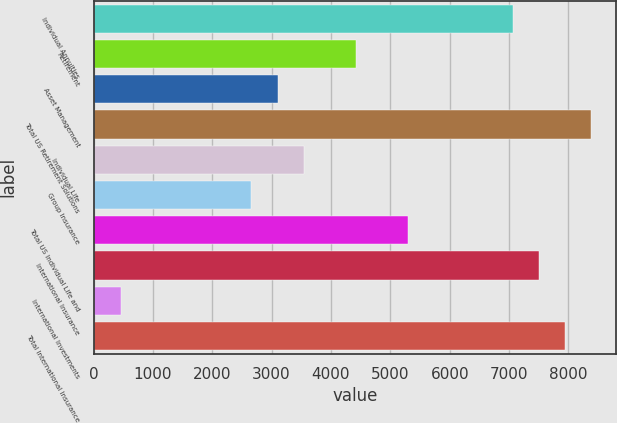Convert chart. <chart><loc_0><loc_0><loc_500><loc_500><bar_chart><fcel>Individual Annuities<fcel>Retirement<fcel>Asset Management<fcel>Total US Retirement Solutions<fcel>Individual Life<fcel>Group Insurance<fcel>Total US Individual Life and<fcel>International Insurance<fcel>International Investments<fcel>Total International Insurance<nl><fcel>7063.2<fcel>4422<fcel>3101.4<fcel>8383.8<fcel>3541.6<fcel>2661.2<fcel>5302.4<fcel>7503.4<fcel>460.2<fcel>7943.6<nl></chart> 